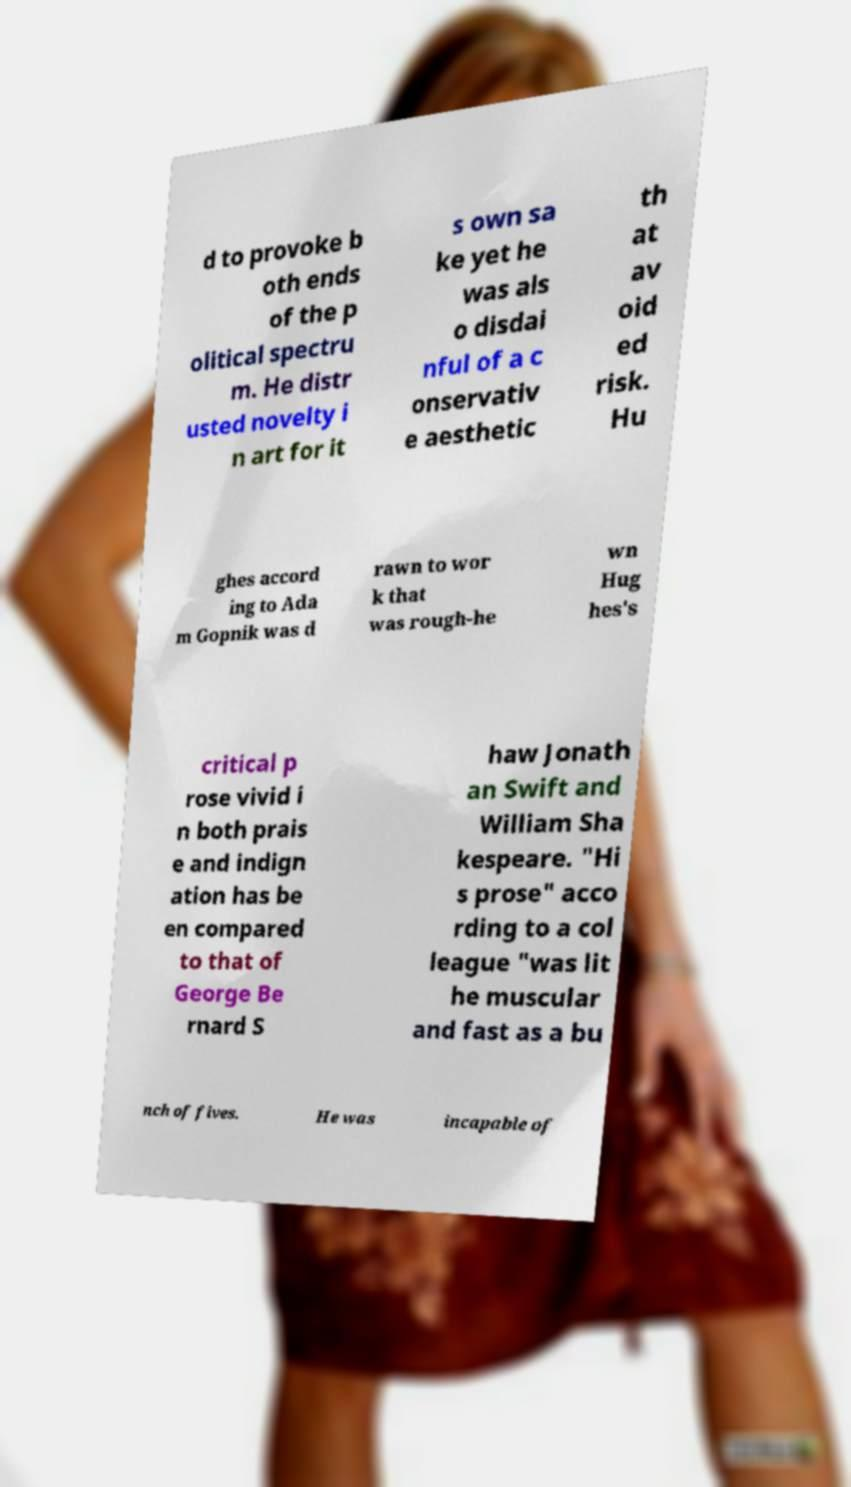Could you assist in decoding the text presented in this image and type it out clearly? d to provoke b oth ends of the p olitical spectru m. He distr usted novelty i n art for it s own sa ke yet he was als o disdai nful of a c onservativ e aesthetic th at av oid ed risk. Hu ghes accord ing to Ada m Gopnik was d rawn to wor k that was rough-he wn Hug hes's critical p rose vivid i n both prais e and indign ation has be en compared to that of George Be rnard S haw Jonath an Swift and William Sha kespeare. "Hi s prose" acco rding to a col league "was lit he muscular and fast as a bu nch of fives. He was incapable of 